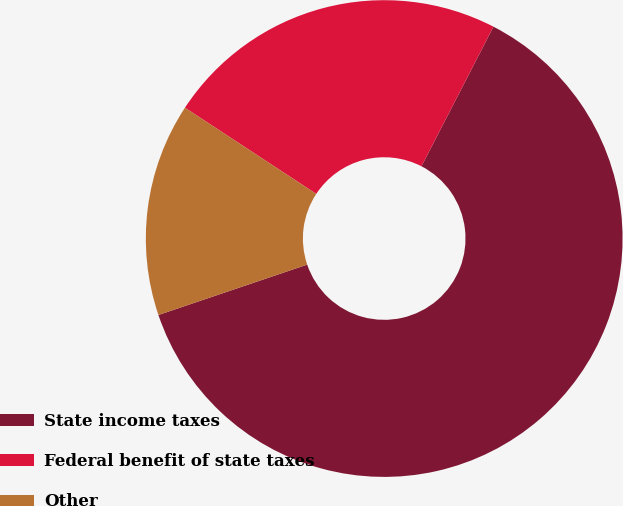<chart> <loc_0><loc_0><loc_500><loc_500><pie_chart><fcel>State income taxes<fcel>Federal benefit of state taxes<fcel>Other<nl><fcel>62.22%<fcel>23.33%<fcel>14.44%<nl></chart> 